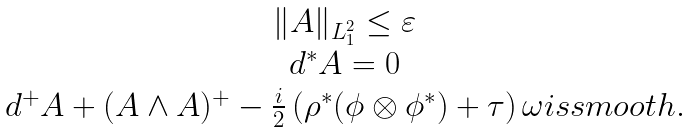<formula> <loc_0><loc_0><loc_500><loc_500>\begin{array} { c } \| A \| _ { L ^ { 2 } _ { 1 } } \leq \varepsilon \\ d ^ { \ast } A = 0 \\ d ^ { + } A + ( A \wedge A ) ^ { + } - \frac { i } { 2 } \left ( \rho ^ { \ast } ( \phi \otimes \phi ^ { \ast } ) + \tau \right ) \omega i s s m o o t h . \end{array}</formula> 